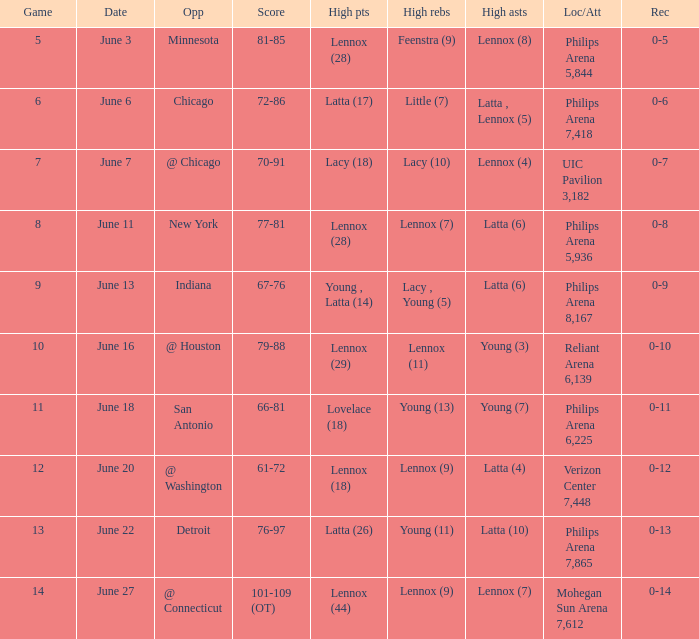Would you be able to parse every entry in this table? {'header': ['Game', 'Date', 'Opp', 'Score', 'High pts', 'High rebs', 'High asts', 'Loc/Att', 'Rec'], 'rows': [['5', 'June 3', 'Minnesota', '81-85', 'Lennox (28)', 'Feenstra (9)', 'Lennox (8)', 'Philips Arena 5,844', '0-5'], ['6', 'June 6', 'Chicago', '72-86', 'Latta (17)', 'Little (7)', 'Latta , Lennox (5)', 'Philips Arena 7,418', '0-6'], ['7', 'June 7', '@ Chicago', '70-91', 'Lacy (18)', 'Lacy (10)', 'Lennox (4)', 'UIC Pavilion 3,182', '0-7'], ['8', 'June 11', 'New York', '77-81', 'Lennox (28)', 'Lennox (7)', 'Latta (6)', 'Philips Arena 5,936', '0-8'], ['9', 'June 13', 'Indiana', '67-76', 'Young , Latta (14)', 'Lacy , Young (5)', 'Latta (6)', 'Philips Arena 8,167', '0-9'], ['10', 'June 16', '@ Houston', '79-88', 'Lennox (29)', 'Lennox (11)', 'Young (3)', 'Reliant Arena 6,139', '0-10'], ['11', 'June 18', 'San Antonio', '66-81', 'Lovelace (18)', 'Young (13)', 'Young (7)', 'Philips Arena 6,225', '0-11'], ['12', 'June 20', '@ Washington', '61-72', 'Lennox (18)', 'Lennox (9)', 'Latta (4)', 'Verizon Center 7,448', '0-12'], ['13', 'June 22', 'Detroit', '76-97', 'Latta (26)', 'Young (11)', 'Latta (10)', 'Philips Arena 7,865', '0-13'], ['14', 'June 27', '@ Connecticut', '101-109 (OT)', 'Lennox (44)', 'Lennox (9)', 'Lennox (7)', 'Mohegan Sun Arena 7,612', '0-14']]} Who made the highest assist in the game that scored 79-88? Young (3). 